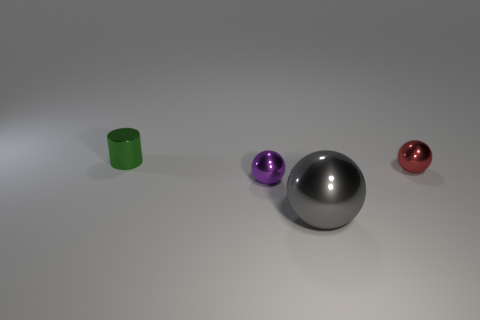Add 1 small blue matte things. How many objects exist? 5 Subtract all balls. How many objects are left? 1 Subtract all metal cylinders. Subtract all purple shiny objects. How many objects are left? 2 Add 2 shiny things. How many shiny things are left? 6 Add 1 big objects. How many big objects exist? 2 Subtract all purple balls. How many balls are left? 2 Subtract all red shiny balls. How many balls are left? 2 Subtract 0 cyan spheres. How many objects are left? 4 Subtract 1 cylinders. How many cylinders are left? 0 Subtract all purple cylinders. Subtract all brown spheres. How many cylinders are left? 1 